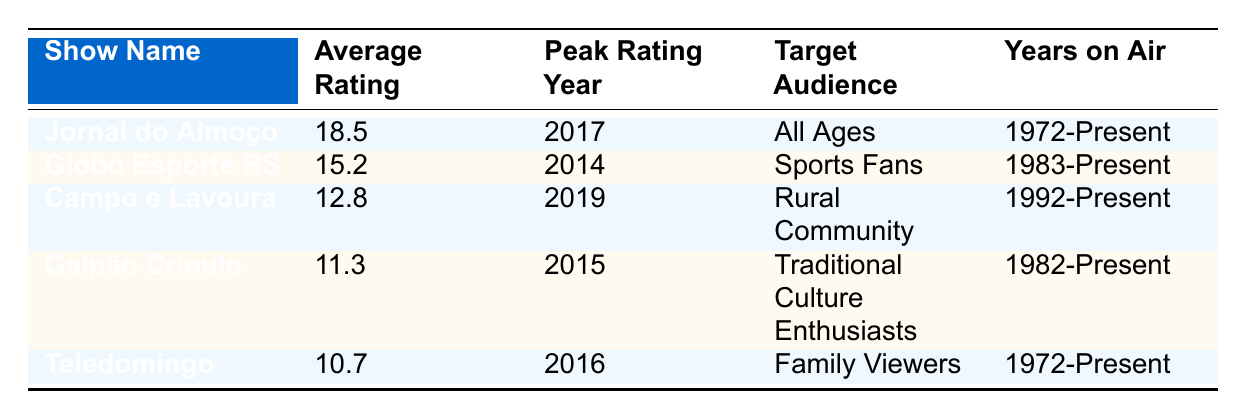What is the average rating of "Jornal do Almoço"? The table lists "Jornal do Almoço" under the show name column, with its corresponding average rating listed as 18.5.
Answer: 18.5 Which show had the peak rating in 2014? According to the table, "Globo Esporte RS" is the only show listed with a peak rating year of 2014.
Answer: Globo Esporte RS How many shows have an average rating greater than 12? Looking at the average ratings in the table, "Jornal do Almoço" (18.5), "Globo Esporte RS" (15.2), and "Campo e Lavoura" (12.8) all exceed 12. Thus, there are three shows.
Answer: 3 Did "Galpão Crioulo" have its peak rating before 2016? The peak rating year for "Galpão Crioulo" is 2015, which is indeed before 2016.
Answer: Yes Which show targets "Family Viewers" and what is its average rating? The table shows that "Teledomingo" targets "Family Viewers" and has an average rating of 10.7.
Answer: Teledomingo, 10.7 What is the average rating of shows that are focused on the rural community? The only show targeting the rural community is "Campo e Lavoura," which has an average rating of 12.8. Since it is the only show, the average is also 12.8.
Answer: 12.8 Which show has been on air the longest time? Both "Jornal do Almoço" and "Teledomingo" have been on air since 1972 and thus have the same duration.
Answer: Jornal do Almoço and Teledomingo Is the average rating of "Campo e Lavoura" higher than that of "Galpão Crioulo"? The average rating of "Campo e Lavoura" is 12.8, while "Galpão Crioulo" has an average rating of 11.3. Since 12.8 is greater than 11.3, this statement is true.
Answer: Yes If we sum the average ratings of all shows in the table, what is the total? The average ratings are 18.5 + 15.2 + 12.8 + 11.3 + 10.7 = 68.5. Therefore, the total sum of average ratings for all shows is 68.5.
Answer: 68.5 